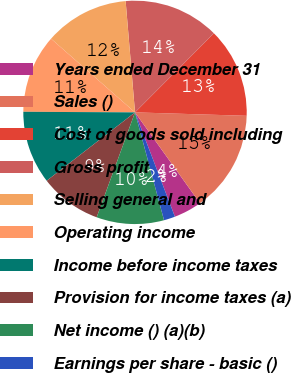Convert chart to OTSL. <chart><loc_0><loc_0><loc_500><loc_500><pie_chart><fcel>Years ended December 31<fcel>Sales ()<fcel>Cost of goods sold including<fcel>Gross profit<fcel>Selling general and<fcel>Operating income<fcel>Income before income taxes<fcel>Provision for income taxes (a)<fcel>Net income () (a)(b)<fcel>Earnings per share - basic ()<nl><fcel>4.07%<fcel>14.63%<fcel>13.01%<fcel>13.82%<fcel>12.2%<fcel>11.38%<fcel>10.57%<fcel>8.94%<fcel>9.76%<fcel>1.63%<nl></chart> 